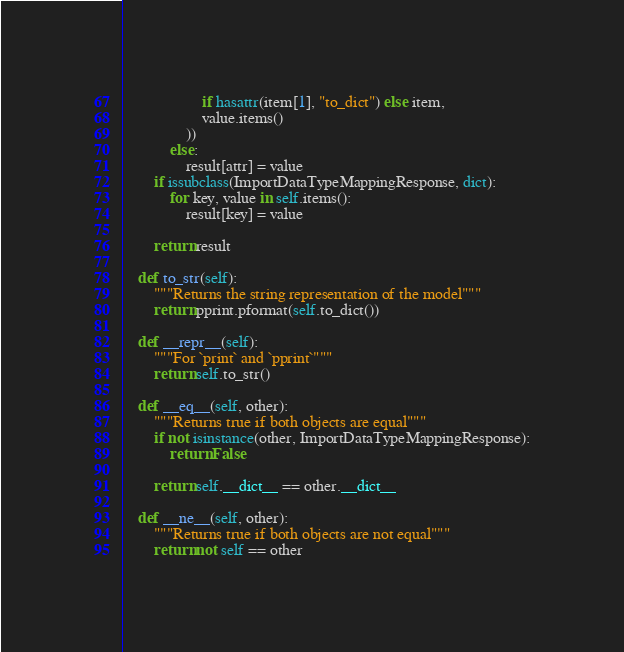<code> <loc_0><loc_0><loc_500><loc_500><_Python_>                    if hasattr(item[1], "to_dict") else item,
                    value.items()
                ))
            else:
                result[attr] = value
        if issubclass(ImportDataTypeMappingResponse, dict):
            for key, value in self.items():
                result[key] = value

        return result

    def to_str(self):
        """Returns the string representation of the model"""
        return pprint.pformat(self.to_dict())

    def __repr__(self):
        """For `print` and `pprint`"""
        return self.to_str()

    def __eq__(self, other):
        """Returns true if both objects are equal"""
        if not isinstance(other, ImportDataTypeMappingResponse):
            return False

        return self.__dict__ == other.__dict__

    def __ne__(self, other):
        """Returns true if both objects are not equal"""
        return not self == other
</code> 